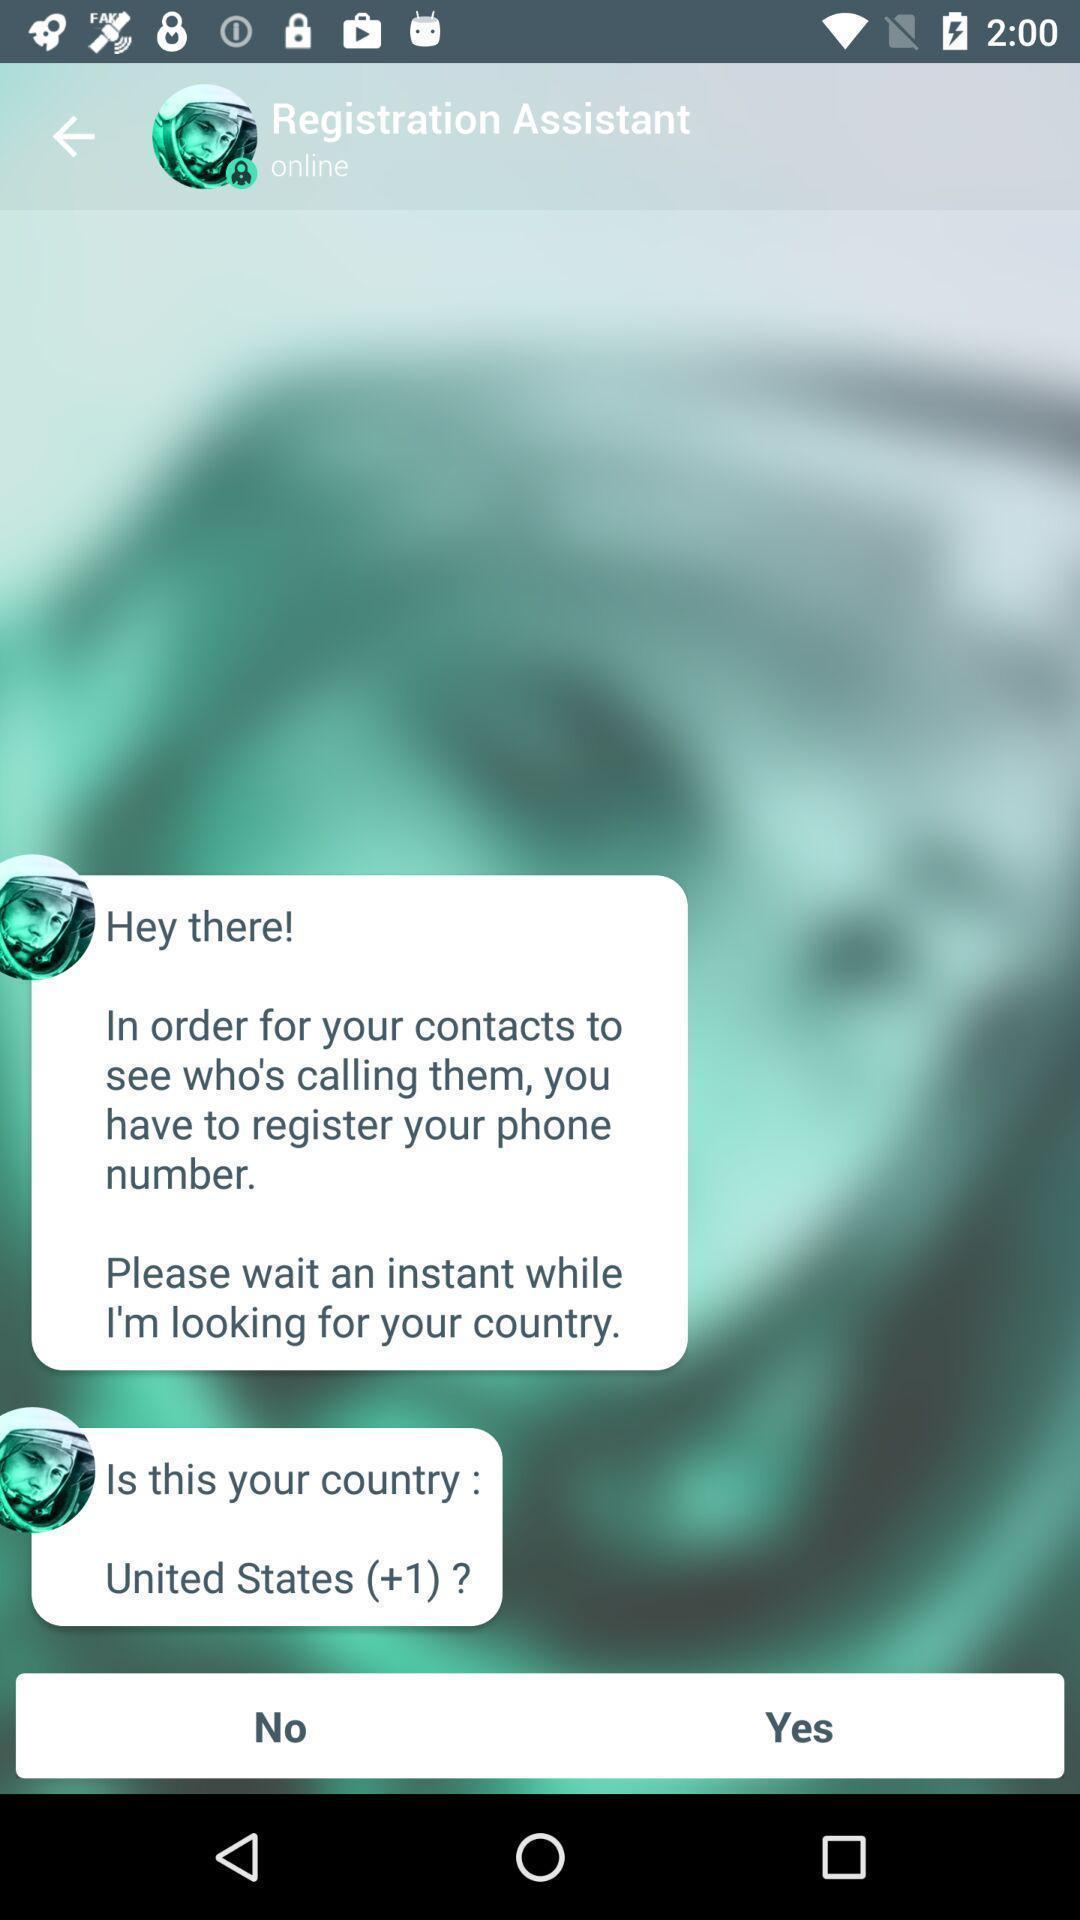What can you discern from this picture? Screen showing various automated messages. 